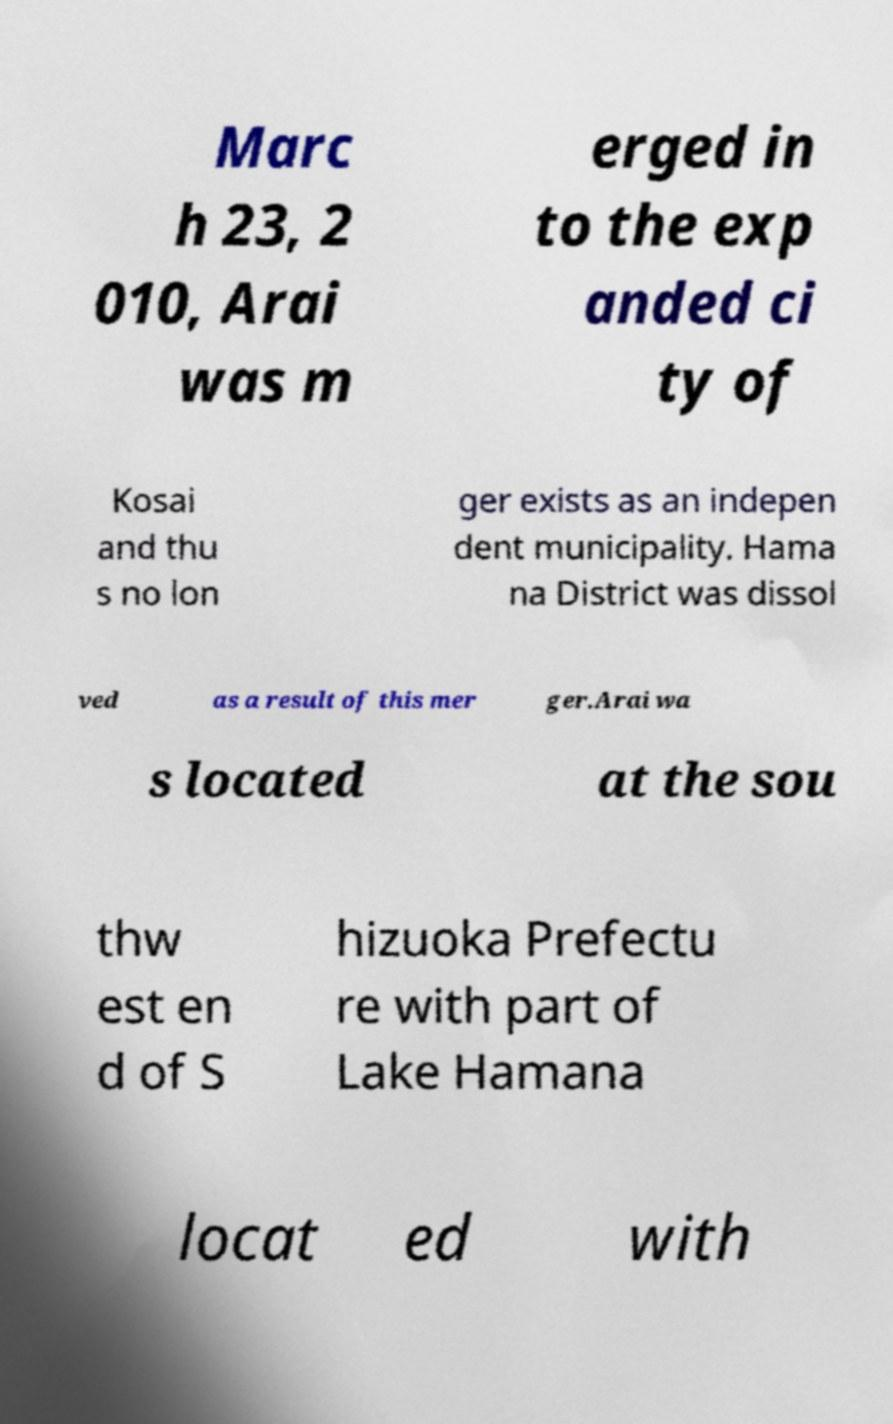Please read and relay the text visible in this image. What does it say? Marc h 23, 2 010, Arai was m erged in to the exp anded ci ty of Kosai and thu s no lon ger exists as an indepen dent municipality. Hama na District was dissol ved as a result of this mer ger.Arai wa s located at the sou thw est en d of S hizuoka Prefectu re with part of Lake Hamana locat ed with 